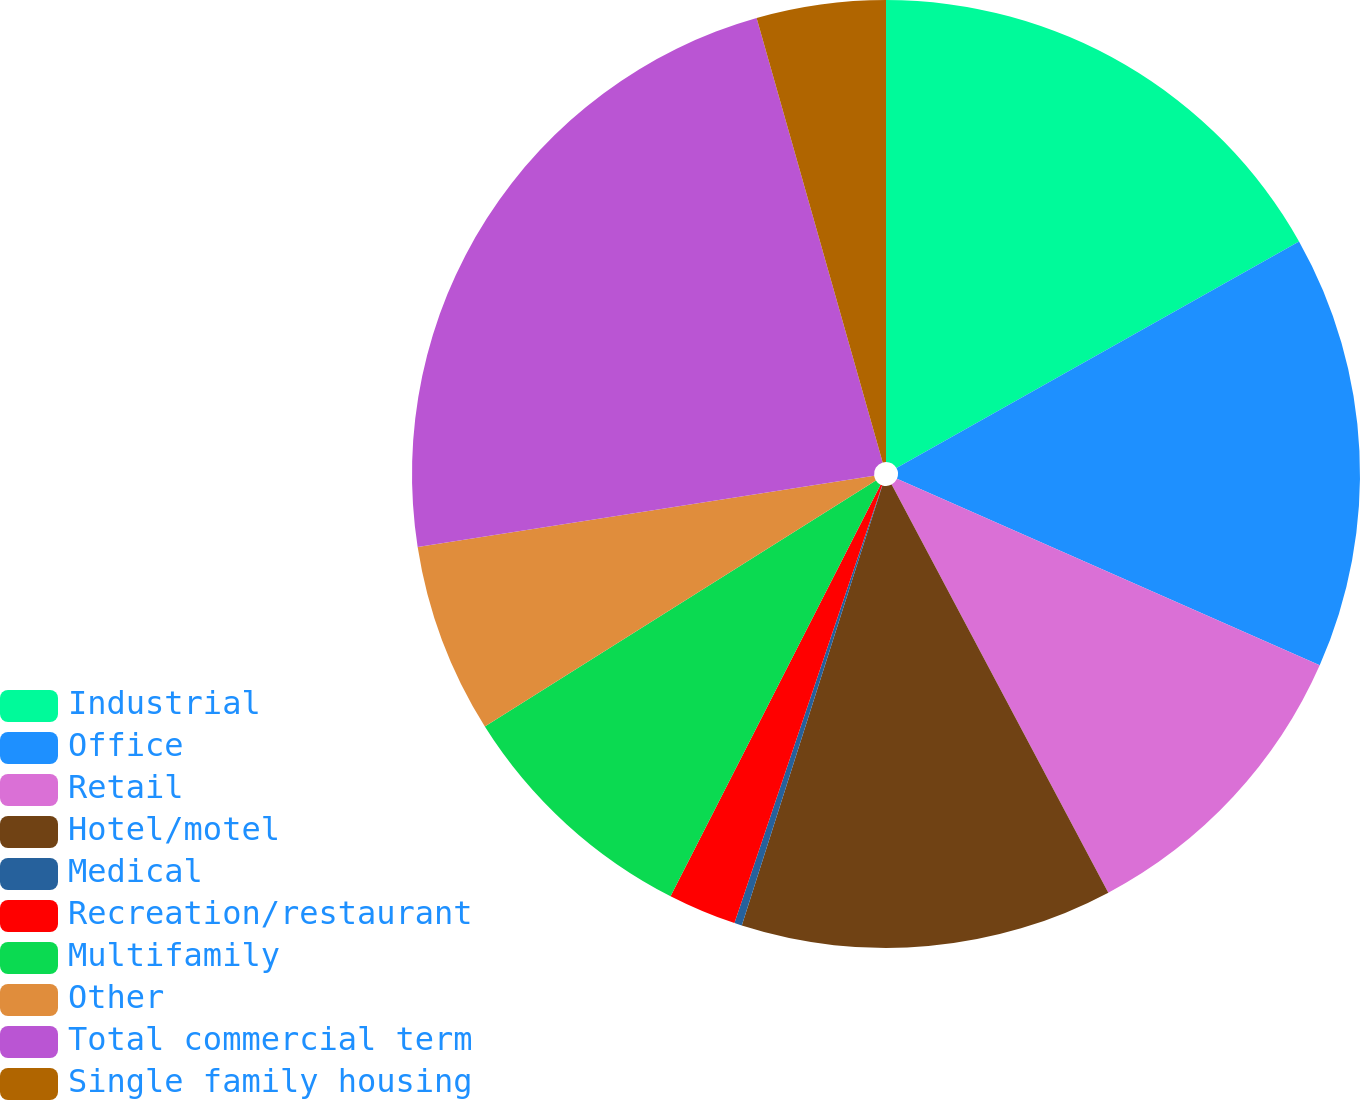Convert chart to OTSL. <chart><loc_0><loc_0><loc_500><loc_500><pie_chart><fcel>Industrial<fcel>Office<fcel>Retail<fcel>Hotel/motel<fcel>Medical<fcel>Recreation/restaurant<fcel>Multifamily<fcel>Other<fcel>Total commercial term<fcel>Single family housing<nl><fcel>16.84%<fcel>14.77%<fcel>10.62%<fcel>12.69%<fcel>0.26%<fcel>2.33%<fcel>8.55%<fcel>6.48%<fcel>23.06%<fcel>4.4%<nl></chart> 